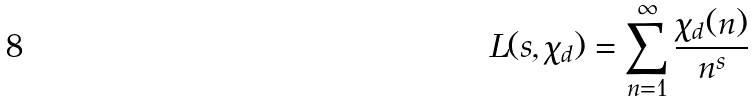<formula> <loc_0><loc_0><loc_500><loc_500>L ( s , \chi _ { d } ) = \sum _ { n = 1 } ^ { \infty } \frac { \chi _ { d } ( n ) } { n ^ { s } }</formula> 